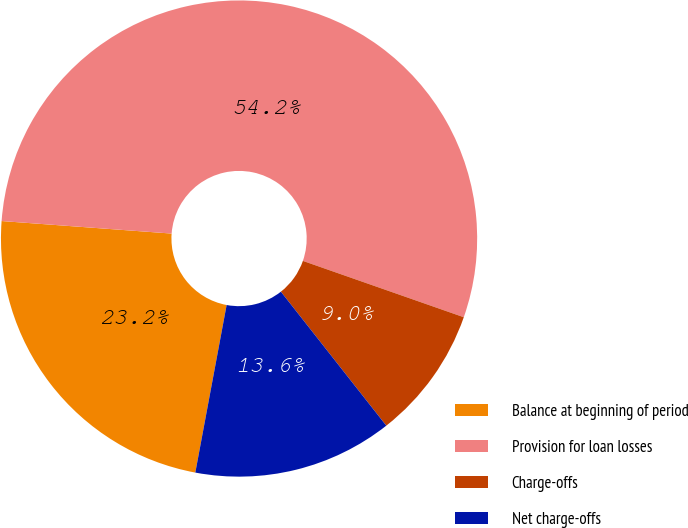<chart> <loc_0><loc_0><loc_500><loc_500><pie_chart><fcel>Balance at beginning of period<fcel>Provision for loan losses<fcel>Charge-offs<fcel>Net charge-offs<nl><fcel>23.23%<fcel>54.19%<fcel>9.03%<fcel>13.55%<nl></chart> 